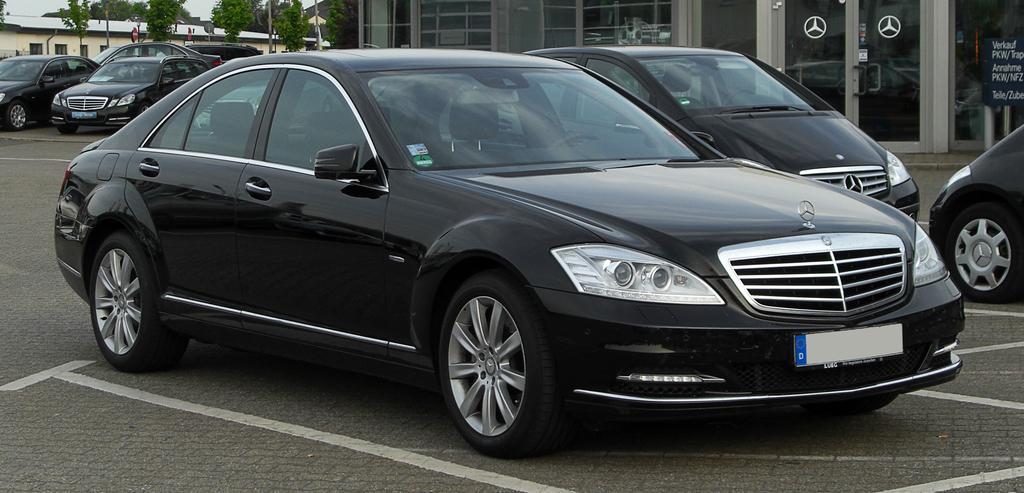How would you summarize this image in a sentence or two? In this image, I can see the black cars on the road. This is a building with glass doors. I can see the logo of Mercedes Benz on the glass door. This looks like a board. These are the trees. I can see a small house with windows. 